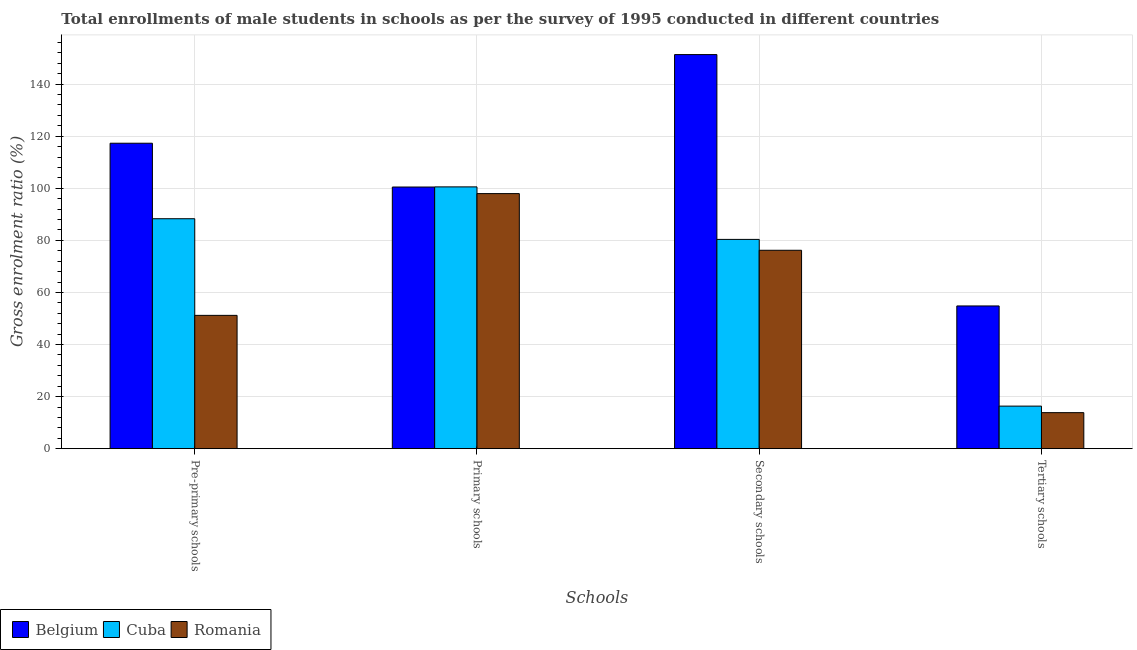How many groups of bars are there?
Ensure brevity in your answer.  4. Are the number of bars per tick equal to the number of legend labels?
Give a very brief answer. Yes. How many bars are there on the 4th tick from the left?
Keep it short and to the point. 3. What is the label of the 2nd group of bars from the left?
Offer a terse response. Primary schools. What is the gross enrolment ratio(male) in primary schools in Belgium?
Offer a very short reply. 100.47. Across all countries, what is the maximum gross enrolment ratio(male) in primary schools?
Keep it short and to the point. 100.52. Across all countries, what is the minimum gross enrolment ratio(male) in tertiary schools?
Give a very brief answer. 13.84. In which country was the gross enrolment ratio(male) in tertiary schools minimum?
Ensure brevity in your answer.  Romania. What is the total gross enrolment ratio(male) in secondary schools in the graph?
Your response must be concise. 307.87. What is the difference between the gross enrolment ratio(male) in primary schools in Romania and that in Cuba?
Give a very brief answer. -2.58. What is the difference between the gross enrolment ratio(male) in tertiary schools in Cuba and the gross enrolment ratio(male) in pre-primary schools in Belgium?
Your answer should be compact. -100.95. What is the average gross enrolment ratio(male) in secondary schools per country?
Offer a very short reply. 102.62. What is the difference between the gross enrolment ratio(male) in secondary schools and gross enrolment ratio(male) in tertiary schools in Belgium?
Ensure brevity in your answer.  96.52. What is the ratio of the gross enrolment ratio(male) in secondary schools in Romania to that in Belgium?
Keep it short and to the point. 0.5. Is the gross enrolment ratio(male) in tertiary schools in Romania less than that in Belgium?
Provide a short and direct response. Yes. What is the difference between the highest and the second highest gross enrolment ratio(male) in pre-primary schools?
Provide a succinct answer. 28.99. What is the difference between the highest and the lowest gross enrolment ratio(male) in primary schools?
Provide a short and direct response. 2.58. Is the sum of the gross enrolment ratio(male) in pre-primary schools in Belgium and Cuba greater than the maximum gross enrolment ratio(male) in primary schools across all countries?
Provide a succinct answer. Yes. What does the 2nd bar from the left in Primary schools represents?
Your answer should be very brief. Cuba. What does the 2nd bar from the right in Pre-primary schools represents?
Keep it short and to the point. Cuba. Is it the case that in every country, the sum of the gross enrolment ratio(male) in pre-primary schools and gross enrolment ratio(male) in primary schools is greater than the gross enrolment ratio(male) in secondary schools?
Give a very brief answer. Yes. How many bars are there?
Your answer should be compact. 12. Are all the bars in the graph horizontal?
Your answer should be compact. No. Are the values on the major ticks of Y-axis written in scientific E-notation?
Keep it short and to the point. No. How are the legend labels stacked?
Your answer should be compact. Horizontal. What is the title of the graph?
Offer a very short reply. Total enrollments of male students in schools as per the survey of 1995 conducted in different countries. Does "Cayman Islands" appear as one of the legend labels in the graph?
Your response must be concise. No. What is the label or title of the X-axis?
Your answer should be compact. Schools. What is the label or title of the Y-axis?
Give a very brief answer. Gross enrolment ratio (%). What is the Gross enrolment ratio (%) of Belgium in Pre-primary schools?
Your answer should be very brief. 117.29. What is the Gross enrolment ratio (%) of Cuba in Pre-primary schools?
Ensure brevity in your answer.  88.3. What is the Gross enrolment ratio (%) in Romania in Pre-primary schools?
Your answer should be compact. 51.19. What is the Gross enrolment ratio (%) in Belgium in Primary schools?
Provide a short and direct response. 100.47. What is the Gross enrolment ratio (%) of Cuba in Primary schools?
Keep it short and to the point. 100.52. What is the Gross enrolment ratio (%) of Romania in Primary schools?
Provide a succinct answer. 97.94. What is the Gross enrolment ratio (%) of Belgium in Secondary schools?
Provide a short and direct response. 151.33. What is the Gross enrolment ratio (%) in Cuba in Secondary schools?
Ensure brevity in your answer.  80.36. What is the Gross enrolment ratio (%) of Romania in Secondary schools?
Keep it short and to the point. 76.18. What is the Gross enrolment ratio (%) in Belgium in Tertiary schools?
Ensure brevity in your answer.  54.8. What is the Gross enrolment ratio (%) of Cuba in Tertiary schools?
Your response must be concise. 16.34. What is the Gross enrolment ratio (%) in Romania in Tertiary schools?
Keep it short and to the point. 13.84. Across all Schools, what is the maximum Gross enrolment ratio (%) in Belgium?
Your answer should be very brief. 151.33. Across all Schools, what is the maximum Gross enrolment ratio (%) of Cuba?
Your answer should be compact. 100.52. Across all Schools, what is the maximum Gross enrolment ratio (%) in Romania?
Your answer should be compact. 97.94. Across all Schools, what is the minimum Gross enrolment ratio (%) in Belgium?
Give a very brief answer. 54.8. Across all Schools, what is the minimum Gross enrolment ratio (%) of Cuba?
Offer a terse response. 16.34. Across all Schools, what is the minimum Gross enrolment ratio (%) in Romania?
Offer a very short reply. 13.84. What is the total Gross enrolment ratio (%) of Belgium in the graph?
Your response must be concise. 423.89. What is the total Gross enrolment ratio (%) in Cuba in the graph?
Offer a very short reply. 285.52. What is the total Gross enrolment ratio (%) of Romania in the graph?
Keep it short and to the point. 239.16. What is the difference between the Gross enrolment ratio (%) in Belgium in Pre-primary schools and that in Primary schools?
Offer a terse response. 16.82. What is the difference between the Gross enrolment ratio (%) in Cuba in Pre-primary schools and that in Primary schools?
Offer a very short reply. -12.23. What is the difference between the Gross enrolment ratio (%) in Romania in Pre-primary schools and that in Primary schools?
Ensure brevity in your answer.  -46.75. What is the difference between the Gross enrolment ratio (%) in Belgium in Pre-primary schools and that in Secondary schools?
Make the answer very short. -34.04. What is the difference between the Gross enrolment ratio (%) in Cuba in Pre-primary schools and that in Secondary schools?
Your answer should be very brief. 7.94. What is the difference between the Gross enrolment ratio (%) in Romania in Pre-primary schools and that in Secondary schools?
Ensure brevity in your answer.  -24.99. What is the difference between the Gross enrolment ratio (%) of Belgium in Pre-primary schools and that in Tertiary schools?
Give a very brief answer. 62.48. What is the difference between the Gross enrolment ratio (%) of Cuba in Pre-primary schools and that in Tertiary schools?
Your answer should be compact. 71.96. What is the difference between the Gross enrolment ratio (%) of Romania in Pre-primary schools and that in Tertiary schools?
Provide a succinct answer. 37.35. What is the difference between the Gross enrolment ratio (%) in Belgium in Primary schools and that in Secondary schools?
Your answer should be very brief. -50.86. What is the difference between the Gross enrolment ratio (%) in Cuba in Primary schools and that in Secondary schools?
Offer a very short reply. 20.17. What is the difference between the Gross enrolment ratio (%) in Romania in Primary schools and that in Secondary schools?
Make the answer very short. 21.76. What is the difference between the Gross enrolment ratio (%) in Belgium in Primary schools and that in Tertiary schools?
Ensure brevity in your answer.  45.67. What is the difference between the Gross enrolment ratio (%) in Cuba in Primary schools and that in Tertiary schools?
Give a very brief answer. 84.19. What is the difference between the Gross enrolment ratio (%) of Romania in Primary schools and that in Tertiary schools?
Offer a terse response. 84.11. What is the difference between the Gross enrolment ratio (%) of Belgium in Secondary schools and that in Tertiary schools?
Your answer should be very brief. 96.52. What is the difference between the Gross enrolment ratio (%) in Cuba in Secondary schools and that in Tertiary schools?
Provide a succinct answer. 64.02. What is the difference between the Gross enrolment ratio (%) in Romania in Secondary schools and that in Tertiary schools?
Your answer should be compact. 62.35. What is the difference between the Gross enrolment ratio (%) in Belgium in Pre-primary schools and the Gross enrolment ratio (%) in Cuba in Primary schools?
Your answer should be very brief. 16.76. What is the difference between the Gross enrolment ratio (%) in Belgium in Pre-primary schools and the Gross enrolment ratio (%) in Romania in Primary schools?
Offer a terse response. 19.34. What is the difference between the Gross enrolment ratio (%) in Cuba in Pre-primary schools and the Gross enrolment ratio (%) in Romania in Primary schools?
Ensure brevity in your answer.  -9.65. What is the difference between the Gross enrolment ratio (%) of Belgium in Pre-primary schools and the Gross enrolment ratio (%) of Cuba in Secondary schools?
Offer a terse response. 36.93. What is the difference between the Gross enrolment ratio (%) of Belgium in Pre-primary schools and the Gross enrolment ratio (%) of Romania in Secondary schools?
Keep it short and to the point. 41.11. What is the difference between the Gross enrolment ratio (%) of Cuba in Pre-primary schools and the Gross enrolment ratio (%) of Romania in Secondary schools?
Make the answer very short. 12.12. What is the difference between the Gross enrolment ratio (%) of Belgium in Pre-primary schools and the Gross enrolment ratio (%) of Cuba in Tertiary schools?
Offer a very short reply. 100.95. What is the difference between the Gross enrolment ratio (%) in Belgium in Pre-primary schools and the Gross enrolment ratio (%) in Romania in Tertiary schools?
Your answer should be very brief. 103.45. What is the difference between the Gross enrolment ratio (%) in Cuba in Pre-primary schools and the Gross enrolment ratio (%) in Romania in Tertiary schools?
Offer a very short reply. 74.46. What is the difference between the Gross enrolment ratio (%) of Belgium in Primary schools and the Gross enrolment ratio (%) of Cuba in Secondary schools?
Offer a terse response. 20.11. What is the difference between the Gross enrolment ratio (%) in Belgium in Primary schools and the Gross enrolment ratio (%) in Romania in Secondary schools?
Provide a short and direct response. 24.29. What is the difference between the Gross enrolment ratio (%) of Cuba in Primary schools and the Gross enrolment ratio (%) of Romania in Secondary schools?
Offer a terse response. 24.34. What is the difference between the Gross enrolment ratio (%) in Belgium in Primary schools and the Gross enrolment ratio (%) in Cuba in Tertiary schools?
Keep it short and to the point. 84.13. What is the difference between the Gross enrolment ratio (%) of Belgium in Primary schools and the Gross enrolment ratio (%) of Romania in Tertiary schools?
Offer a very short reply. 86.64. What is the difference between the Gross enrolment ratio (%) in Cuba in Primary schools and the Gross enrolment ratio (%) in Romania in Tertiary schools?
Provide a short and direct response. 86.69. What is the difference between the Gross enrolment ratio (%) in Belgium in Secondary schools and the Gross enrolment ratio (%) in Cuba in Tertiary schools?
Give a very brief answer. 134.99. What is the difference between the Gross enrolment ratio (%) of Belgium in Secondary schools and the Gross enrolment ratio (%) of Romania in Tertiary schools?
Offer a very short reply. 137.49. What is the difference between the Gross enrolment ratio (%) of Cuba in Secondary schools and the Gross enrolment ratio (%) of Romania in Tertiary schools?
Offer a very short reply. 66.52. What is the average Gross enrolment ratio (%) in Belgium per Schools?
Your response must be concise. 105.97. What is the average Gross enrolment ratio (%) of Cuba per Schools?
Your answer should be compact. 71.38. What is the average Gross enrolment ratio (%) in Romania per Schools?
Offer a very short reply. 59.79. What is the difference between the Gross enrolment ratio (%) in Belgium and Gross enrolment ratio (%) in Cuba in Pre-primary schools?
Your response must be concise. 28.99. What is the difference between the Gross enrolment ratio (%) of Belgium and Gross enrolment ratio (%) of Romania in Pre-primary schools?
Provide a succinct answer. 66.1. What is the difference between the Gross enrolment ratio (%) in Cuba and Gross enrolment ratio (%) in Romania in Pre-primary schools?
Offer a very short reply. 37.11. What is the difference between the Gross enrolment ratio (%) of Belgium and Gross enrolment ratio (%) of Cuba in Primary schools?
Make the answer very short. -0.05. What is the difference between the Gross enrolment ratio (%) of Belgium and Gross enrolment ratio (%) of Romania in Primary schools?
Your response must be concise. 2.53. What is the difference between the Gross enrolment ratio (%) in Cuba and Gross enrolment ratio (%) in Romania in Primary schools?
Your answer should be compact. 2.58. What is the difference between the Gross enrolment ratio (%) in Belgium and Gross enrolment ratio (%) in Cuba in Secondary schools?
Offer a very short reply. 70.97. What is the difference between the Gross enrolment ratio (%) of Belgium and Gross enrolment ratio (%) of Romania in Secondary schools?
Ensure brevity in your answer.  75.15. What is the difference between the Gross enrolment ratio (%) in Cuba and Gross enrolment ratio (%) in Romania in Secondary schools?
Your response must be concise. 4.17. What is the difference between the Gross enrolment ratio (%) in Belgium and Gross enrolment ratio (%) in Cuba in Tertiary schools?
Make the answer very short. 38.47. What is the difference between the Gross enrolment ratio (%) of Belgium and Gross enrolment ratio (%) of Romania in Tertiary schools?
Keep it short and to the point. 40.97. What is the difference between the Gross enrolment ratio (%) in Cuba and Gross enrolment ratio (%) in Romania in Tertiary schools?
Keep it short and to the point. 2.5. What is the ratio of the Gross enrolment ratio (%) of Belgium in Pre-primary schools to that in Primary schools?
Offer a very short reply. 1.17. What is the ratio of the Gross enrolment ratio (%) in Cuba in Pre-primary schools to that in Primary schools?
Provide a succinct answer. 0.88. What is the ratio of the Gross enrolment ratio (%) of Romania in Pre-primary schools to that in Primary schools?
Ensure brevity in your answer.  0.52. What is the ratio of the Gross enrolment ratio (%) in Belgium in Pre-primary schools to that in Secondary schools?
Ensure brevity in your answer.  0.78. What is the ratio of the Gross enrolment ratio (%) in Cuba in Pre-primary schools to that in Secondary schools?
Your answer should be very brief. 1.1. What is the ratio of the Gross enrolment ratio (%) of Romania in Pre-primary schools to that in Secondary schools?
Give a very brief answer. 0.67. What is the ratio of the Gross enrolment ratio (%) in Belgium in Pre-primary schools to that in Tertiary schools?
Your answer should be very brief. 2.14. What is the ratio of the Gross enrolment ratio (%) of Cuba in Pre-primary schools to that in Tertiary schools?
Offer a terse response. 5.4. What is the ratio of the Gross enrolment ratio (%) in Romania in Pre-primary schools to that in Tertiary schools?
Your answer should be compact. 3.7. What is the ratio of the Gross enrolment ratio (%) in Belgium in Primary schools to that in Secondary schools?
Keep it short and to the point. 0.66. What is the ratio of the Gross enrolment ratio (%) of Cuba in Primary schools to that in Secondary schools?
Your response must be concise. 1.25. What is the ratio of the Gross enrolment ratio (%) in Romania in Primary schools to that in Secondary schools?
Make the answer very short. 1.29. What is the ratio of the Gross enrolment ratio (%) of Belgium in Primary schools to that in Tertiary schools?
Make the answer very short. 1.83. What is the ratio of the Gross enrolment ratio (%) in Cuba in Primary schools to that in Tertiary schools?
Your answer should be very brief. 6.15. What is the ratio of the Gross enrolment ratio (%) of Romania in Primary schools to that in Tertiary schools?
Your answer should be very brief. 7.08. What is the ratio of the Gross enrolment ratio (%) in Belgium in Secondary schools to that in Tertiary schools?
Give a very brief answer. 2.76. What is the ratio of the Gross enrolment ratio (%) of Cuba in Secondary schools to that in Tertiary schools?
Your answer should be compact. 4.92. What is the ratio of the Gross enrolment ratio (%) in Romania in Secondary schools to that in Tertiary schools?
Offer a terse response. 5.51. What is the difference between the highest and the second highest Gross enrolment ratio (%) in Belgium?
Offer a terse response. 34.04. What is the difference between the highest and the second highest Gross enrolment ratio (%) of Cuba?
Give a very brief answer. 12.23. What is the difference between the highest and the second highest Gross enrolment ratio (%) in Romania?
Give a very brief answer. 21.76. What is the difference between the highest and the lowest Gross enrolment ratio (%) of Belgium?
Provide a succinct answer. 96.52. What is the difference between the highest and the lowest Gross enrolment ratio (%) of Cuba?
Your answer should be compact. 84.19. What is the difference between the highest and the lowest Gross enrolment ratio (%) of Romania?
Your response must be concise. 84.11. 